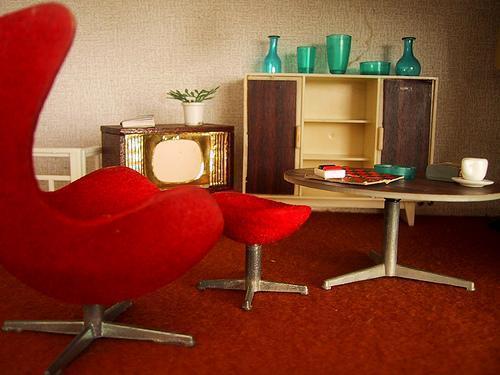This style of furniture was popular in what era?
Pick the correct solution from the four options below to address the question.
Options: 12th century, 20th century, 19th century, 18th century. 20th century. 